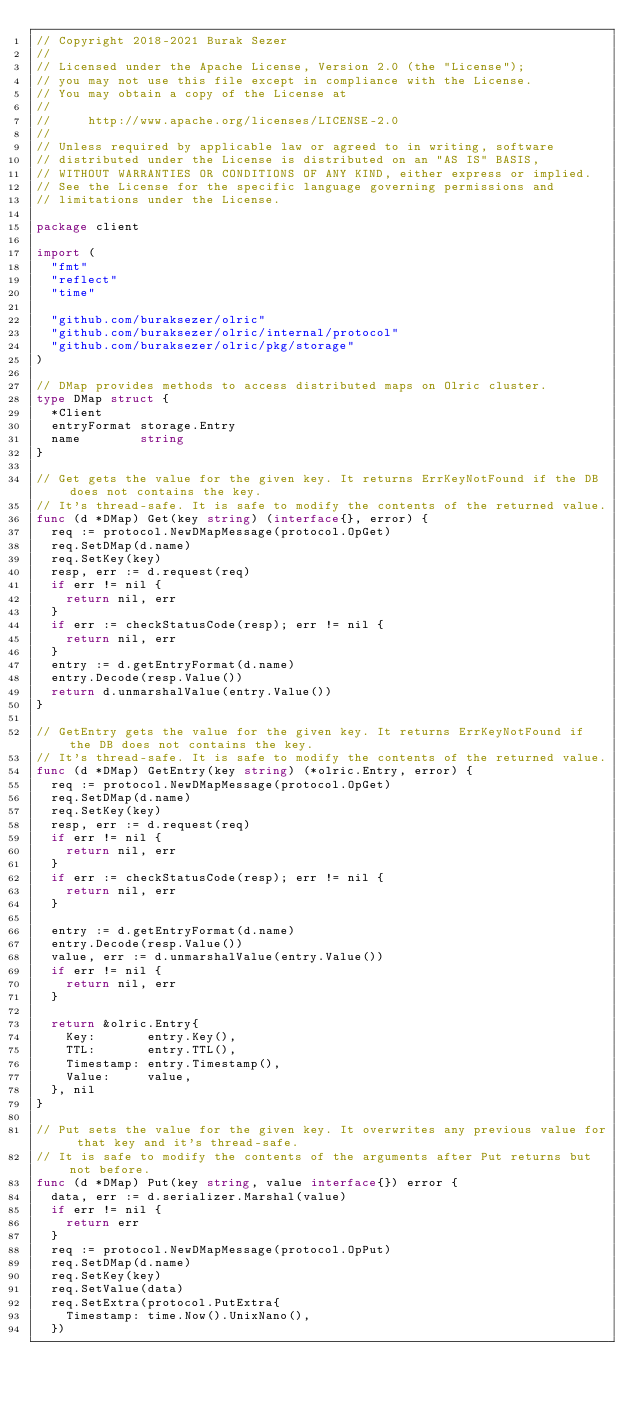Convert code to text. <code><loc_0><loc_0><loc_500><loc_500><_Go_>// Copyright 2018-2021 Burak Sezer
//
// Licensed under the Apache License, Version 2.0 (the "License");
// you may not use this file except in compliance with the License.
// You may obtain a copy of the License at
//
//     http://www.apache.org/licenses/LICENSE-2.0
//
// Unless required by applicable law or agreed to in writing, software
// distributed under the License is distributed on an "AS IS" BASIS,
// WITHOUT WARRANTIES OR CONDITIONS OF ANY KIND, either express or implied.
// See the License for the specific language governing permissions and
// limitations under the License.

package client

import (
	"fmt"
	"reflect"
	"time"

	"github.com/buraksezer/olric"
	"github.com/buraksezer/olric/internal/protocol"
	"github.com/buraksezer/olric/pkg/storage"
)

// DMap provides methods to access distributed maps on Olric cluster.
type DMap struct {
	*Client
	entryFormat storage.Entry
	name        string
}

// Get gets the value for the given key. It returns ErrKeyNotFound if the DB does not contains the key.
// It's thread-safe. It is safe to modify the contents of the returned value.
func (d *DMap) Get(key string) (interface{}, error) {
	req := protocol.NewDMapMessage(protocol.OpGet)
	req.SetDMap(d.name)
	req.SetKey(key)
	resp, err := d.request(req)
	if err != nil {
		return nil, err
	}
	if err := checkStatusCode(resp); err != nil {
		return nil, err
	}
	entry := d.getEntryFormat(d.name)
	entry.Decode(resp.Value())
	return d.unmarshalValue(entry.Value())
}

// GetEntry gets the value for the given key. It returns ErrKeyNotFound if the DB does not contains the key.
// It's thread-safe. It is safe to modify the contents of the returned value.
func (d *DMap) GetEntry(key string) (*olric.Entry, error) {
	req := protocol.NewDMapMessage(protocol.OpGet)
	req.SetDMap(d.name)
	req.SetKey(key)
	resp, err := d.request(req)
	if err != nil {
		return nil, err
	}
	if err := checkStatusCode(resp); err != nil {
		return nil, err
	}

	entry := d.getEntryFormat(d.name)
	entry.Decode(resp.Value())
	value, err := d.unmarshalValue(entry.Value())
	if err != nil {
		return nil, err
	}

	return &olric.Entry{
		Key:       entry.Key(),
		TTL:       entry.TTL(),
		Timestamp: entry.Timestamp(),
		Value:     value,
	}, nil
}

// Put sets the value for the given key. It overwrites any previous value for that key and it's thread-safe.
// It is safe to modify the contents of the arguments after Put returns but not before.
func (d *DMap) Put(key string, value interface{}) error {
	data, err := d.serializer.Marshal(value)
	if err != nil {
		return err
	}
	req := protocol.NewDMapMessage(protocol.OpPut)
	req.SetDMap(d.name)
	req.SetKey(key)
	req.SetValue(data)
	req.SetExtra(protocol.PutExtra{
		Timestamp: time.Now().UnixNano(),
	})</code> 